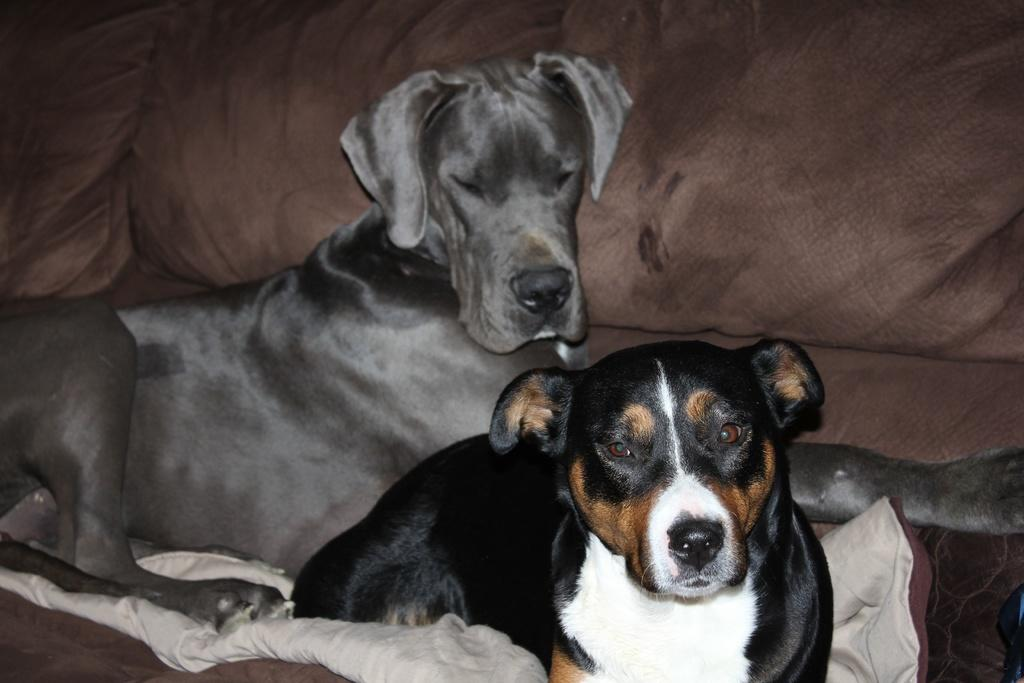How many dogs are present in the image? There are two dogs in the image. What are the dogs doing in the image? The dogs are sitting on a sofa. What type of beam is holding up the ceiling in the image? There is no mention of a ceiling or any beams in the image; it only features two dogs sitting on a sofa. What are the dogs talking about in the image? Dogs do not have the ability to talk, so there is no conversation between them in the image. 